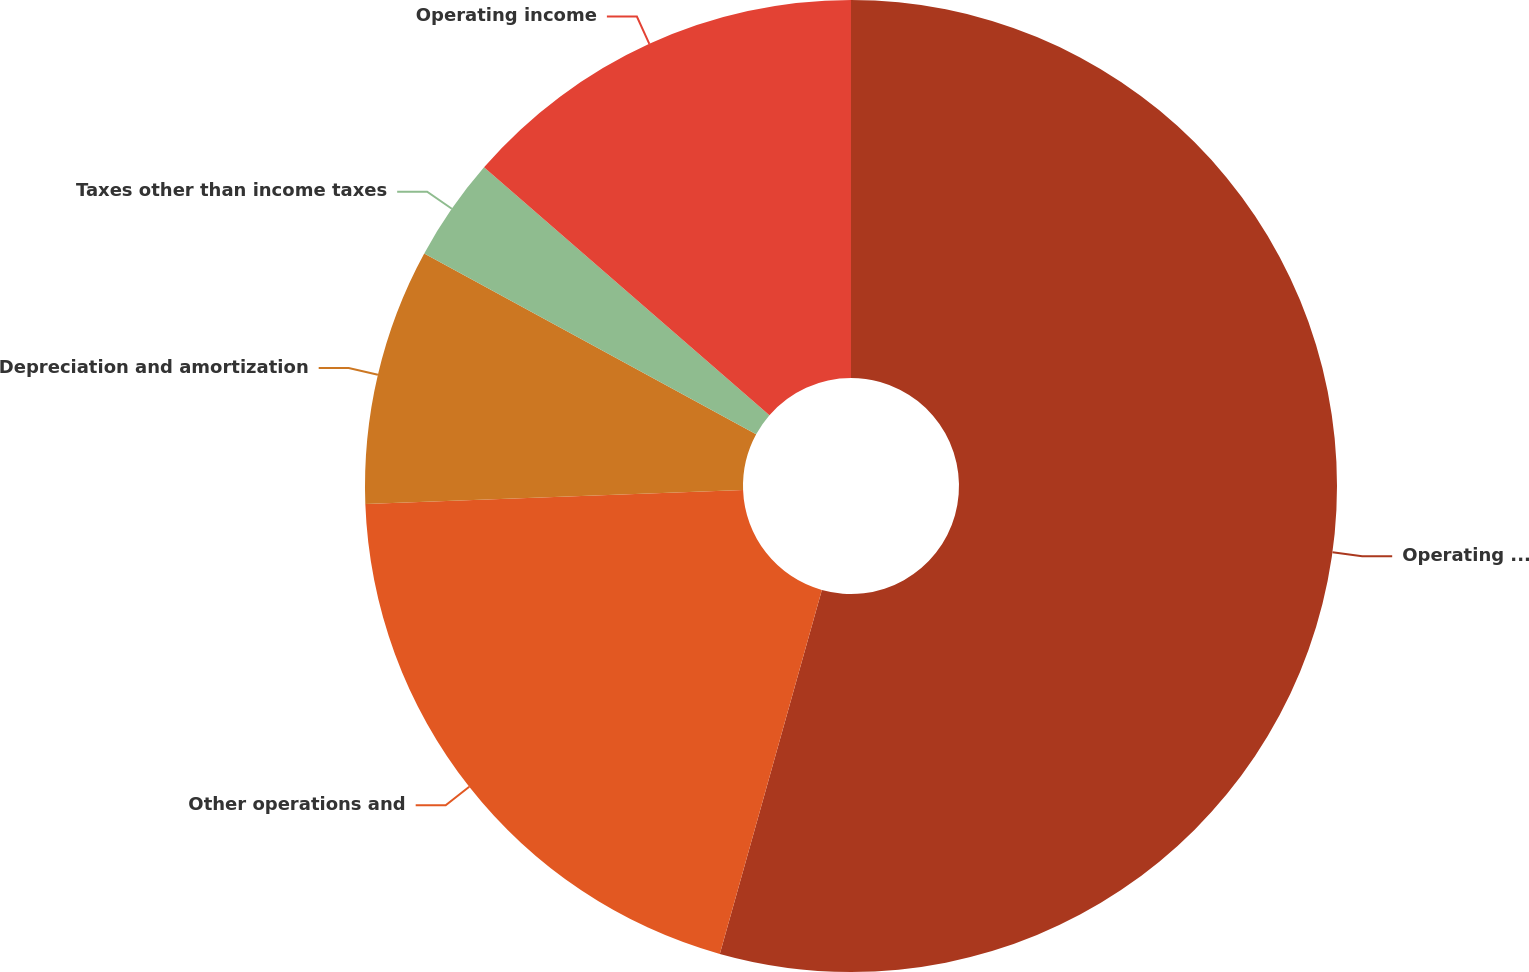Convert chart. <chart><loc_0><loc_0><loc_500><loc_500><pie_chart><fcel>Operating revenues<fcel>Other operations and<fcel>Depreciation and amortization<fcel>Taxes other than income taxes<fcel>Operating income<nl><fcel>54.35%<fcel>20.06%<fcel>8.53%<fcel>3.44%<fcel>13.62%<nl></chart> 